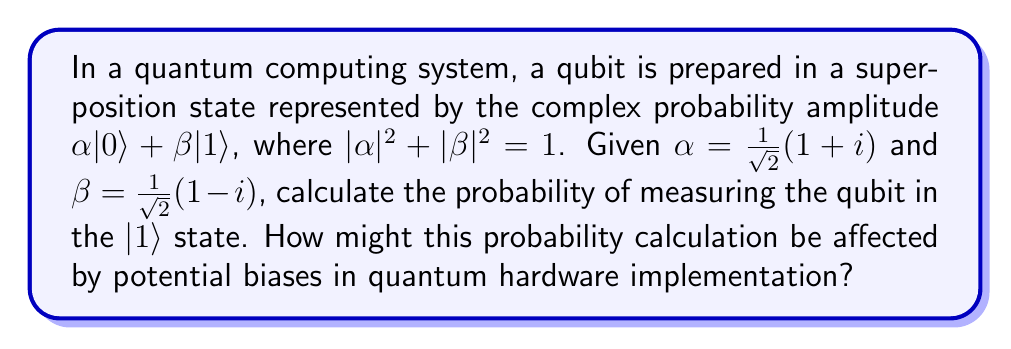Give your solution to this math problem. Let's approach this step-by-step:

1) In quantum computing, the probability of measuring a qubit in a particular state is given by the squared magnitude of its corresponding complex probability amplitude.

2) For the $|1\rangle$ state, we need to calculate $|\beta|^2$.

3) Given: $\beta = \frac{1}{\sqrt{2}}(1 - i)$

4) To find $|\beta|^2$, we multiply $\beta$ by its complex conjugate:

   $|\beta|^2 = \beta \cdot \beta^* = \frac{1}{\sqrt{2}}(1 - i) \cdot \frac{1}{\sqrt{2}}(1 + i)$

5) Simplifying:
   
   $|\beta|^2 = \frac{1}{2}((1 - i)(1 + i)) = \frac{1}{2}(1 - i + i - i^2) = \frac{1}{2}(1 - i + i + 1) = \frac{1}{2} \cdot 2 = 1$

6) Therefore, the probability of measuring the qubit in the $|1\rangle$ state is 1, or 100%.

Regarding potential biases in quantum hardware implementation:

7) In real quantum systems, various factors can introduce biases:
   - Imperfect qubit initialization
   - Decoherence effects
   - Readout errors
   - Gate imperfections

8) These biases could lead to deviations from the ideal probability distribution, potentially resulting in a measured probability less than 100% for the $|1\rangle$ state.

9) Software engineers working on quantum algorithms need to be aware of these potential biases and implement error correction and mitigation techniques to ensure reliable results.
Answer: 1 (or 100%) 